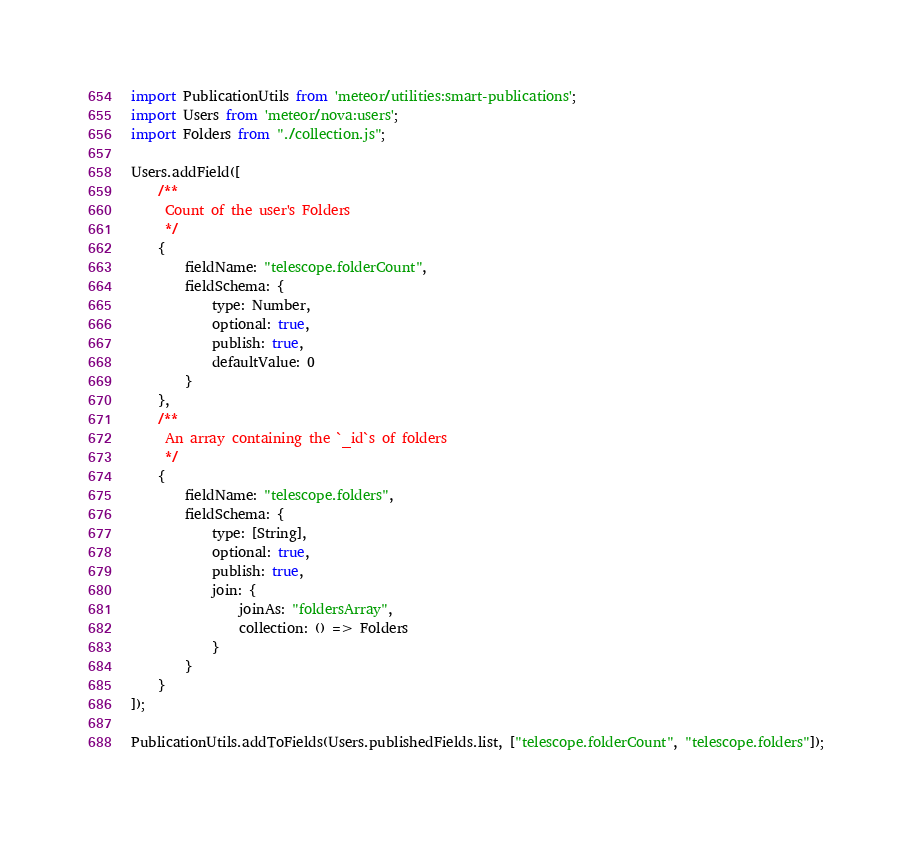Convert code to text. <code><loc_0><loc_0><loc_500><loc_500><_JavaScript_>import PublicationUtils from 'meteor/utilities:smart-publications';
import Users from 'meteor/nova:users';
import Folders from "./collection.js";

Users.addField([
    /**
     Count of the user's Folders
     */
    {
        fieldName: "telescope.folderCount",
        fieldSchema: {
            type: Number,
            optional: true,
            publish: true,
            defaultValue: 0
        }
    },
    /**
     An array containing the `_id`s of folders
     */
    {
        fieldName: "telescope.folders",
        fieldSchema: {
            type: [String],
            optional: true,
            publish: true,
            join: {
                joinAs: "foldersArray",
                collection: () => Folders
            }
        }
    }
]);

PublicationUtils.addToFields(Users.publishedFields.list, ["telescope.folderCount", "telescope.folders"]);
</code> 